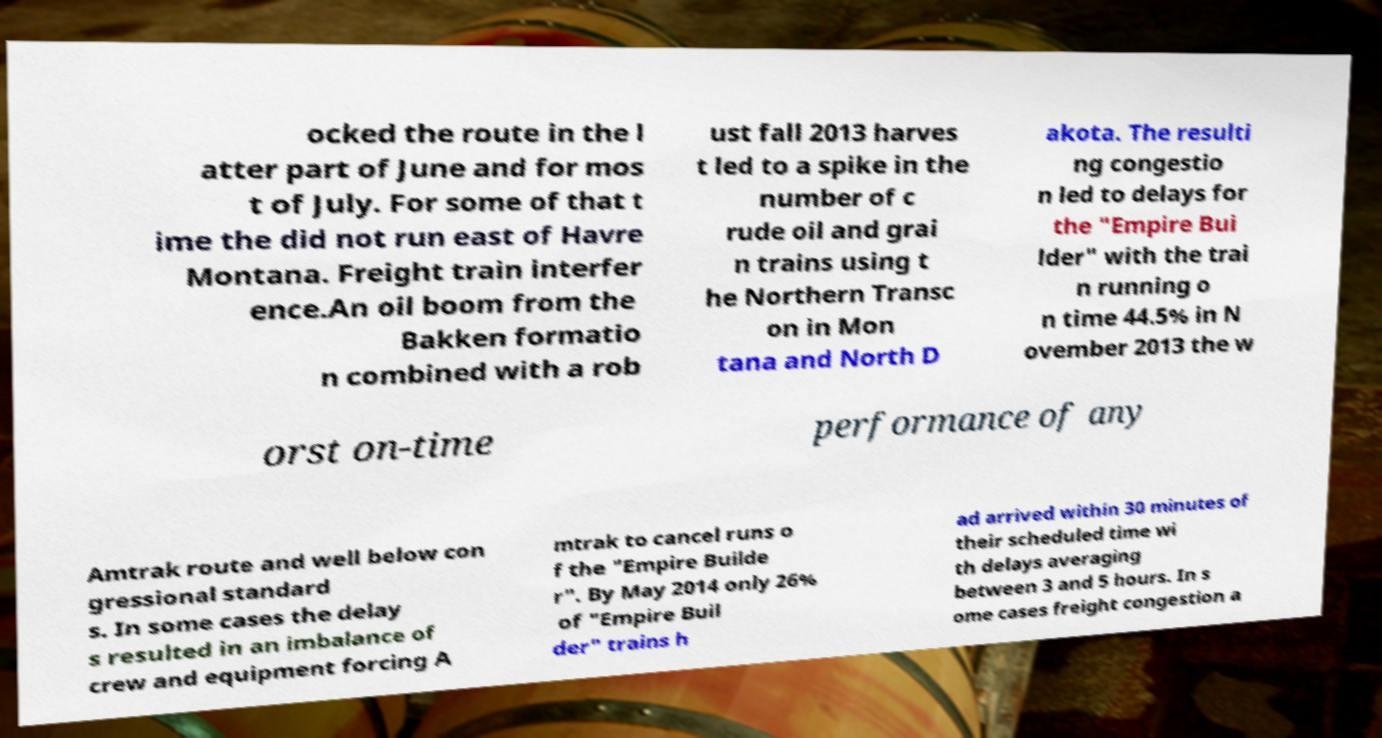For documentation purposes, I need the text within this image transcribed. Could you provide that? ocked the route in the l atter part of June and for mos t of July. For some of that t ime the did not run east of Havre Montana. Freight train interfer ence.An oil boom from the Bakken formatio n combined with a rob ust fall 2013 harves t led to a spike in the number of c rude oil and grai n trains using t he Northern Transc on in Mon tana and North D akota. The resulti ng congestio n led to delays for the "Empire Bui lder" with the trai n running o n time 44.5% in N ovember 2013 the w orst on-time performance of any Amtrak route and well below con gressional standard s. In some cases the delay s resulted in an imbalance of crew and equipment forcing A mtrak to cancel runs o f the "Empire Builde r". By May 2014 only 26% of "Empire Buil der" trains h ad arrived within 30 minutes of their scheduled time wi th delays averaging between 3 and 5 hours. In s ome cases freight congestion a 